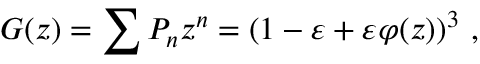Convert formula to latex. <formula><loc_0><loc_0><loc_500><loc_500>G ( z ) = \sum { P _ { n } z ^ { n } } = ( 1 - \varepsilon + \varepsilon \varphi ( z ) ) ^ { 3 } ,</formula> 